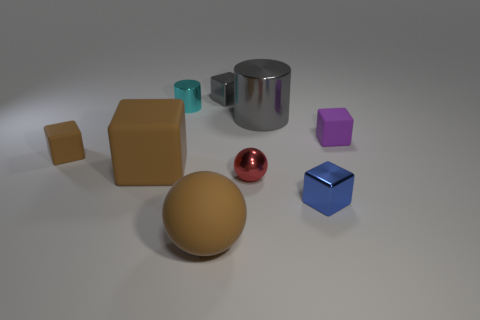Subtract all small metal blocks. How many blocks are left? 3 Add 1 large cylinders. How many objects exist? 10 Subtract all gray blocks. How many blocks are left? 4 Subtract 1 cylinders. How many cylinders are left? 1 Subtract all blue spheres. How many blue cylinders are left? 0 Add 3 tiny metallic objects. How many tiny metallic objects are left? 7 Add 8 tiny blue shiny blocks. How many tiny blue shiny blocks exist? 9 Subtract 1 brown spheres. How many objects are left? 8 Subtract all balls. How many objects are left? 7 Subtract all yellow cylinders. Subtract all red blocks. How many cylinders are left? 2 